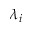<formula> <loc_0><loc_0><loc_500><loc_500>\lambda _ { i }</formula> 